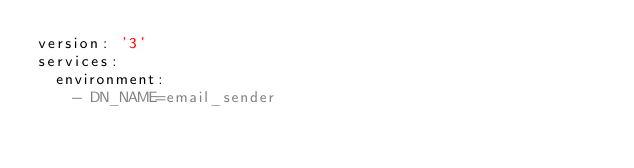<code> <loc_0><loc_0><loc_500><loc_500><_YAML_>version: '3'
services:
  environment: 
    - DN_NAME=email_sender</code> 